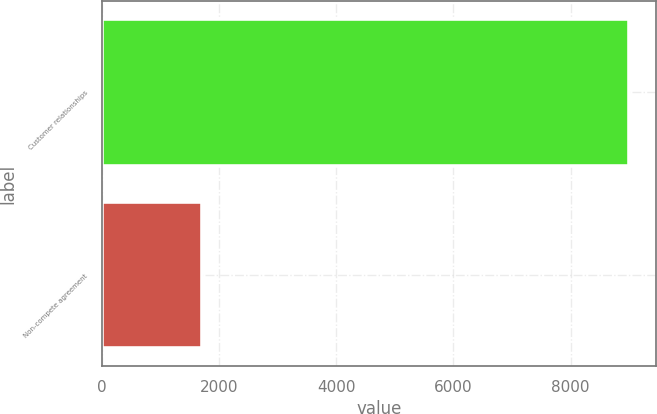<chart> <loc_0><loc_0><loc_500><loc_500><bar_chart><fcel>Customer relationships<fcel>Non-compete agreement<nl><fcel>9000<fcel>1700<nl></chart> 